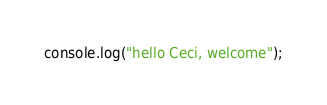<code> <loc_0><loc_0><loc_500><loc_500><_JavaScript_>console.log("hello Ceci, welcome");</code> 